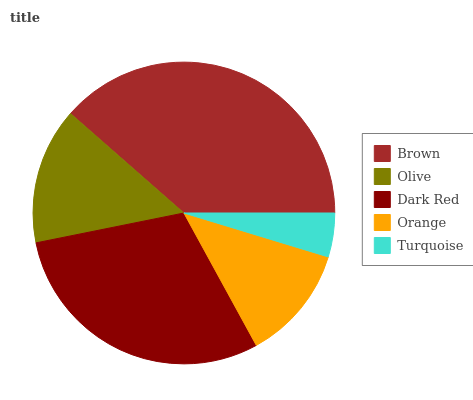Is Turquoise the minimum?
Answer yes or no. Yes. Is Brown the maximum?
Answer yes or no. Yes. Is Olive the minimum?
Answer yes or no. No. Is Olive the maximum?
Answer yes or no. No. Is Brown greater than Olive?
Answer yes or no. Yes. Is Olive less than Brown?
Answer yes or no. Yes. Is Olive greater than Brown?
Answer yes or no. No. Is Brown less than Olive?
Answer yes or no. No. Is Olive the high median?
Answer yes or no. Yes. Is Olive the low median?
Answer yes or no. Yes. Is Dark Red the high median?
Answer yes or no. No. Is Turquoise the low median?
Answer yes or no. No. 